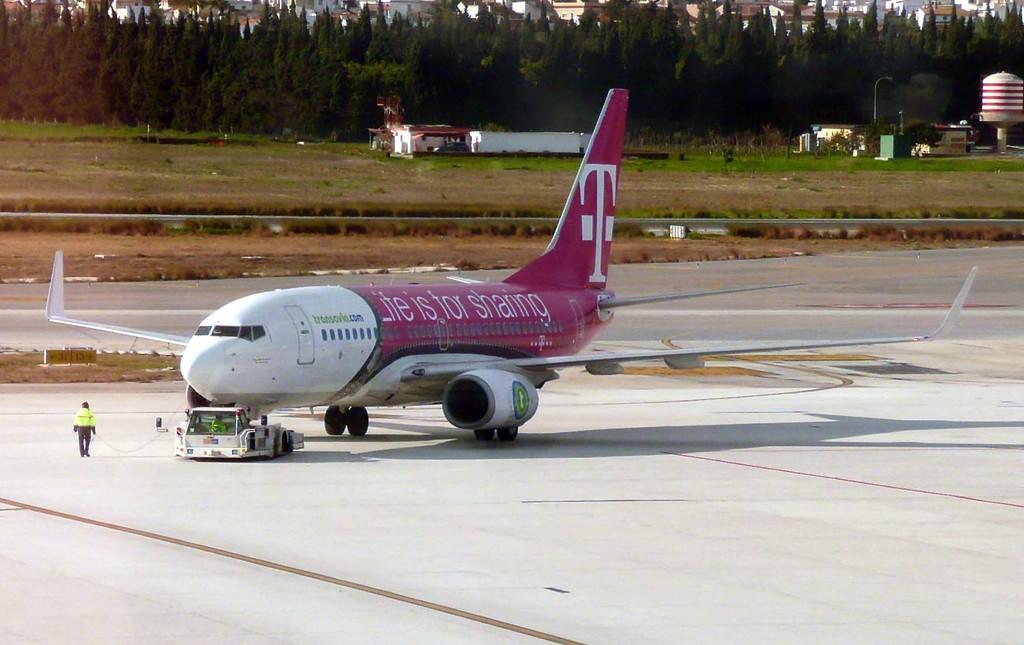What is the slogan on the side say that life is for?
Your answer should be compact. Life is for sharing. What brand is being advertised on the plane?
Provide a succinct answer. T-mobile. 